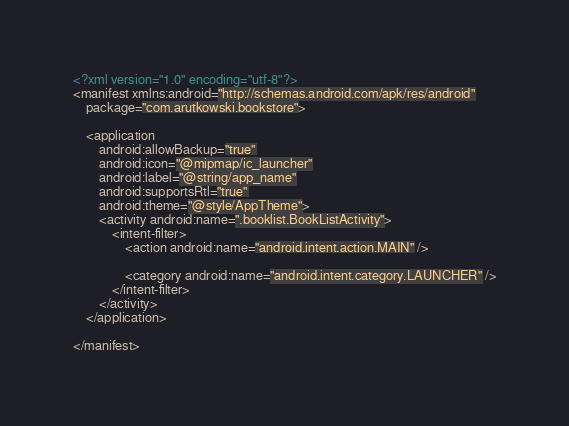Convert code to text. <code><loc_0><loc_0><loc_500><loc_500><_XML_><?xml version="1.0" encoding="utf-8"?>
<manifest xmlns:android="http://schemas.android.com/apk/res/android"
    package="com.arutkowski.bookstore">

    <application
        android:allowBackup="true"
        android:icon="@mipmap/ic_launcher"
        android:label="@string/app_name"
        android:supportsRtl="true"
        android:theme="@style/AppTheme">
        <activity android:name=".booklist.BookListActivity">
            <intent-filter>
                <action android:name="android.intent.action.MAIN" />

                <category android:name="android.intent.category.LAUNCHER" />
            </intent-filter>
        </activity>
    </application>

</manifest></code> 